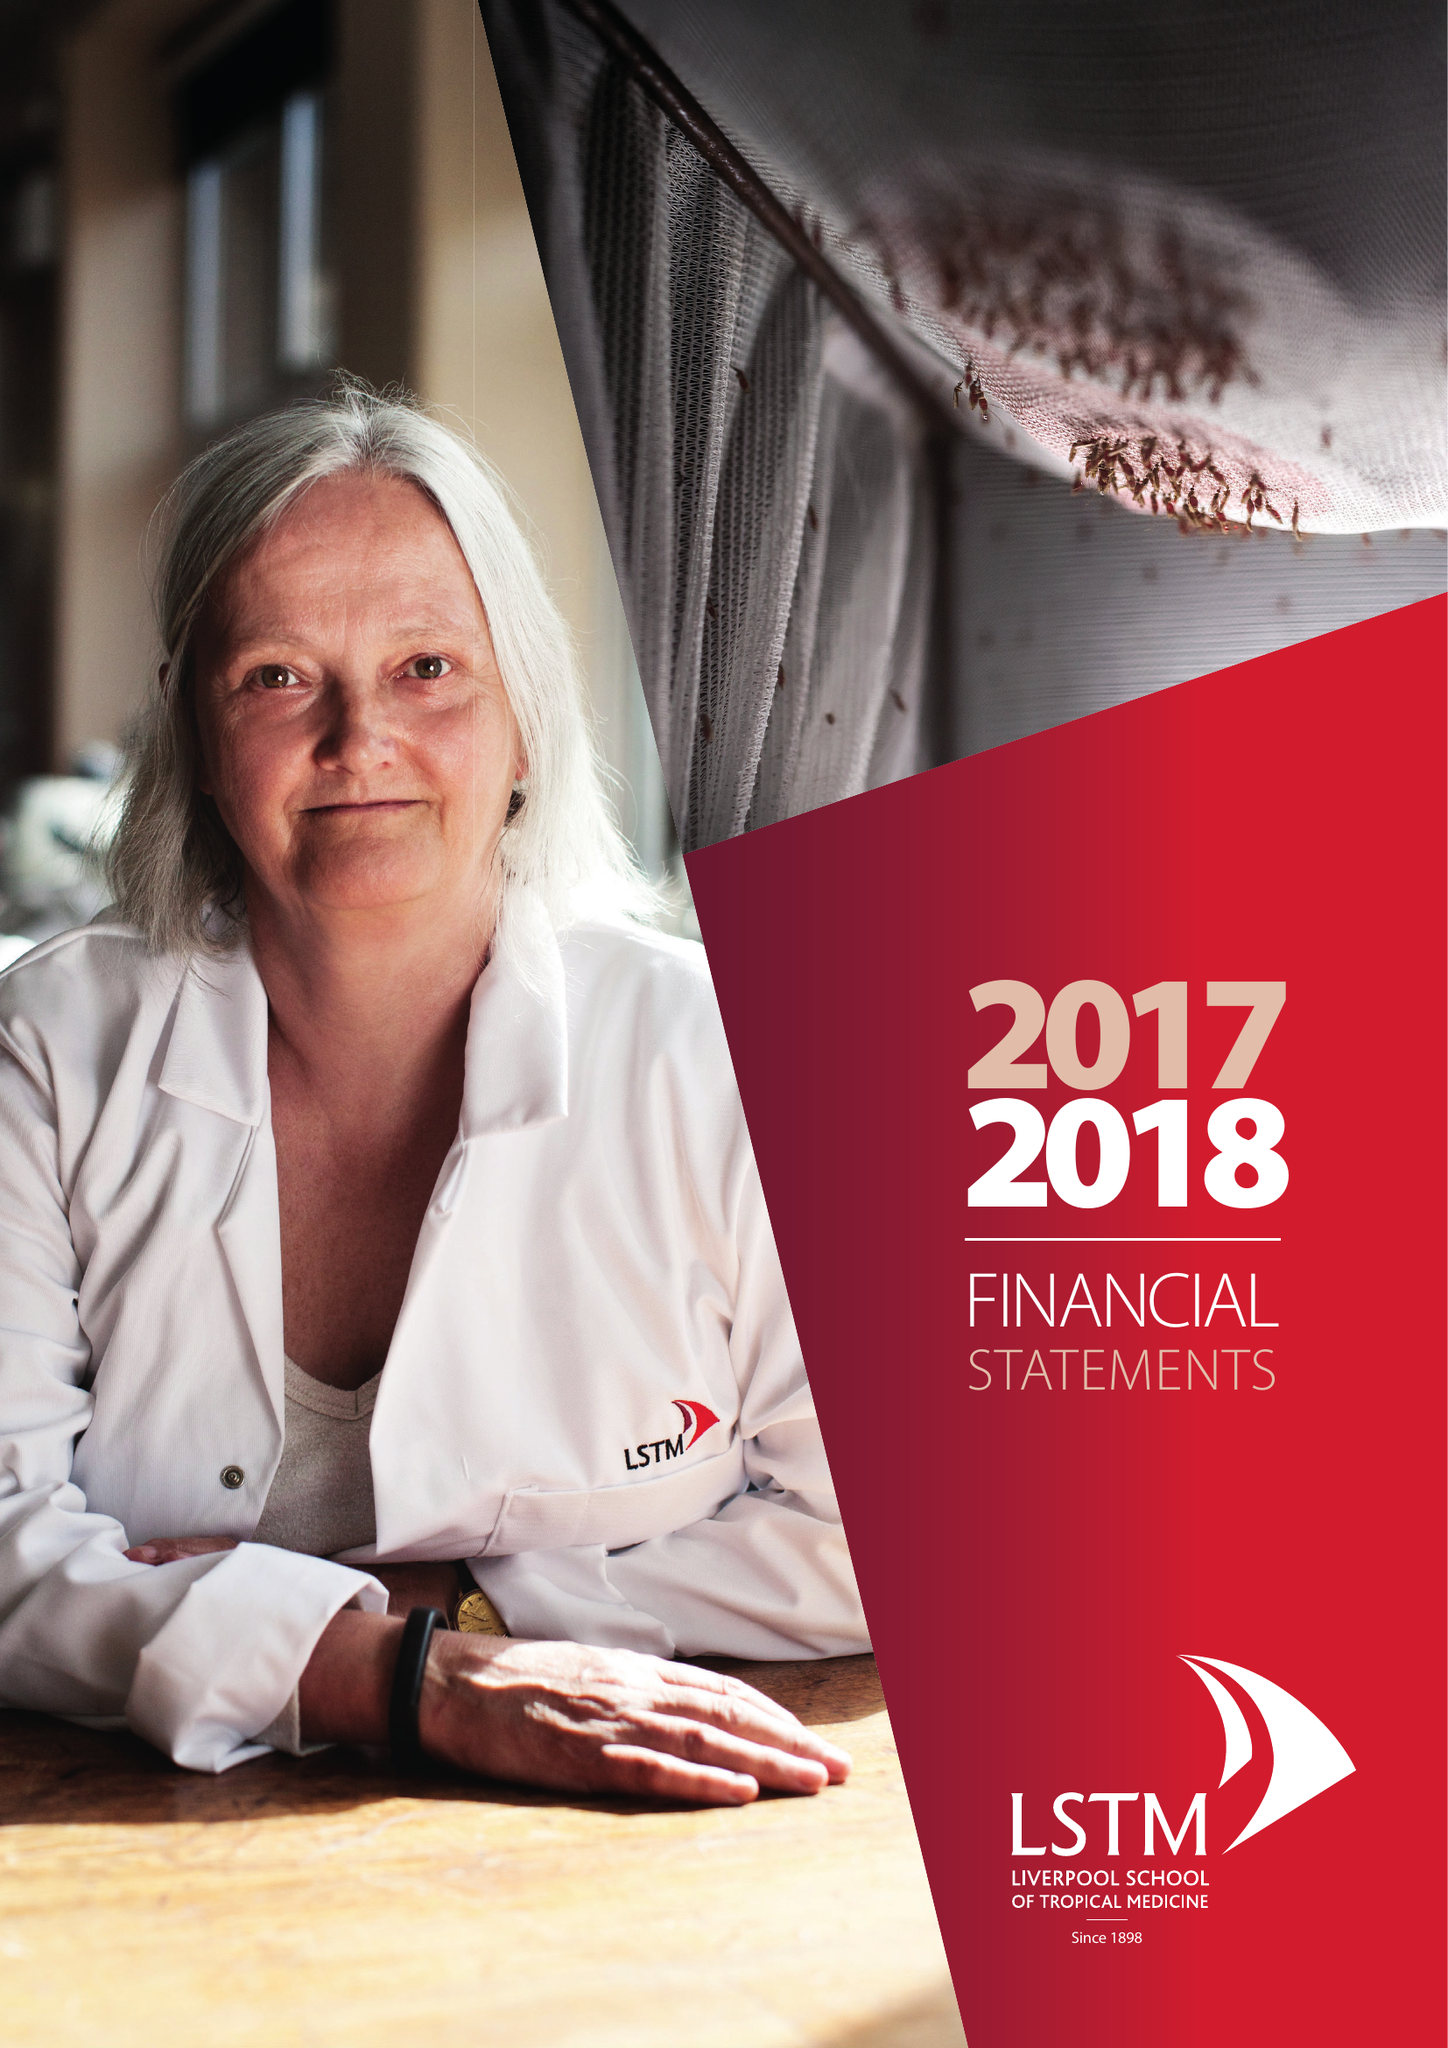What is the value for the report_date?
Answer the question using a single word or phrase. 2018-07-31 